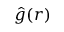<formula> <loc_0><loc_0><loc_500><loc_500>{ \hat { g } } ( { r } )</formula> 